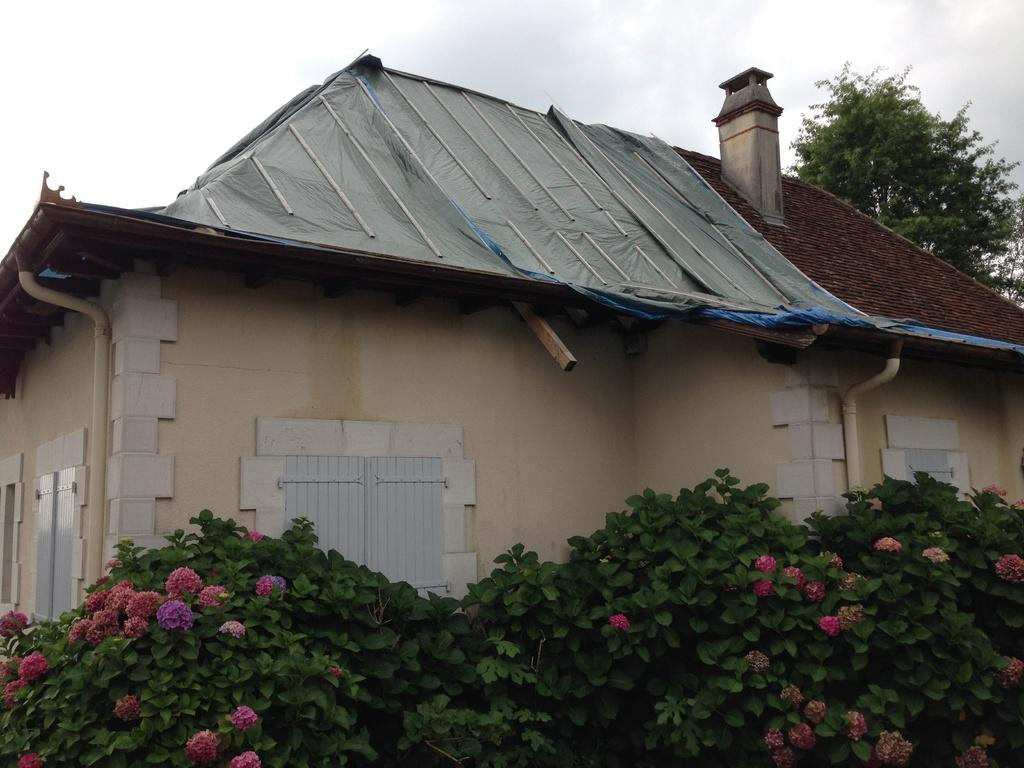What type of living organisms can be seen in the image? Plants and flowers are visible in the image. What color are the plants in the image? The plants are green. What colors are the flowers in the image? The flowers are pink and red. What can be seen in the background of the image? There is a house in the background of the image. What color is the house in the image? The house is cream-colored. What is the color of the sky in the image? The sky is white in the image. What book is the person reading in the image? There is no person or book present in the image; it features plants, flowers, a house, and a white sky. What type of school is depicted in the image? There is no school depicted in the image. 